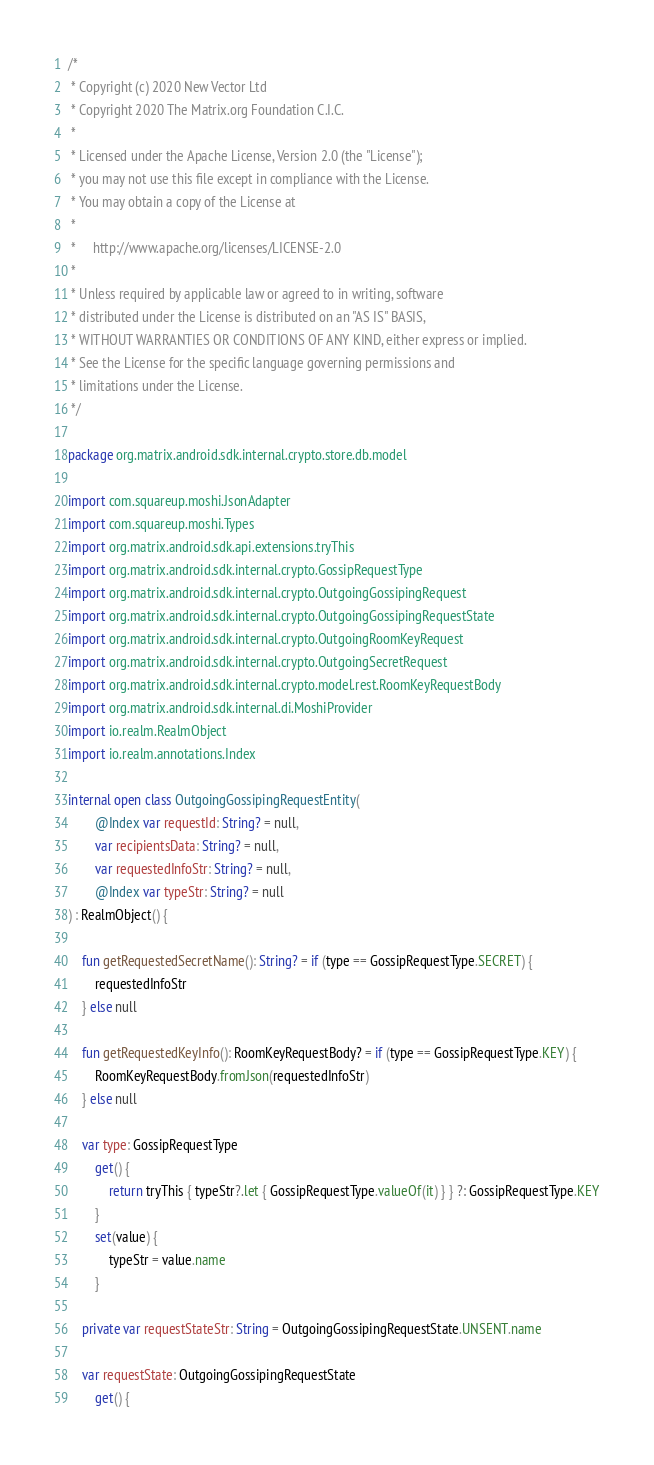Convert code to text. <code><loc_0><loc_0><loc_500><loc_500><_Kotlin_>/*
 * Copyright (c) 2020 New Vector Ltd
 * Copyright 2020 The Matrix.org Foundation C.I.C.
 *
 * Licensed under the Apache License, Version 2.0 (the "License");
 * you may not use this file except in compliance with the License.
 * You may obtain a copy of the License at
 *
 *     http://www.apache.org/licenses/LICENSE-2.0
 *
 * Unless required by applicable law or agreed to in writing, software
 * distributed under the License is distributed on an "AS IS" BASIS,
 * WITHOUT WARRANTIES OR CONDITIONS OF ANY KIND, either express or implied.
 * See the License for the specific language governing permissions and
 * limitations under the License.
 */

package org.matrix.android.sdk.internal.crypto.store.db.model

import com.squareup.moshi.JsonAdapter
import com.squareup.moshi.Types
import org.matrix.android.sdk.api.extensions.tryThis
import org.matrix.android.sdk.internal.crypto.GossipRequestType
import org.matrix.android.sdk.internal.crypto.OutgoingGossipingRequest
import org.matrix.android.sdk.internal.crypto.OutgoingGossipingRequestState
import org.matrix.android.sdk.internal.crypto.OutgoingRoomKeyRequest
import org.matrix.android.sdk.internal.crypto.OutgoingSecretRequest
import org.matrix.android.sdk.internal.crypto.model.rest.RoomKeyRequestBody
import org.matrix.android.sdk.internal.di.MoshiProvider
import io.realm.RealmObject
import io.realm.annotations.Index

internal open class OutgoingGossipingRequestEntity(
        @Index var requestId: String? = null,
        var recipientsData: String? = null,
        var requestedInfoStr: String? = null,
        @Index var typeStr: String? = null
) : RealmObject() {

    fun getRequestedSecretName(): String? = if (type == GossipRequestType.SECRET) {
        requestedInfoStr
    } else null

    fun getRequestedKeyInfo(): RoomKeyRequestBody? = if (type == GossipRequestType.KEY) {
        RoomKeyRequestBody.fromJson(requestedInfoStr)
    } else null

    var type: GossipRequestType
        get() {
            return tryThis { typeStr?.let { GossipRequestType.valueOf(it) } } ?: GossipRequestType.KEY
        }
        set(value) {
            typeStr = value.name
        }

    private var requestStateStr: String = OutgoingGossipingRequestState.UNSENT.name

    var requestState: OutgoingGossipingRequestState
        get() {</code> 